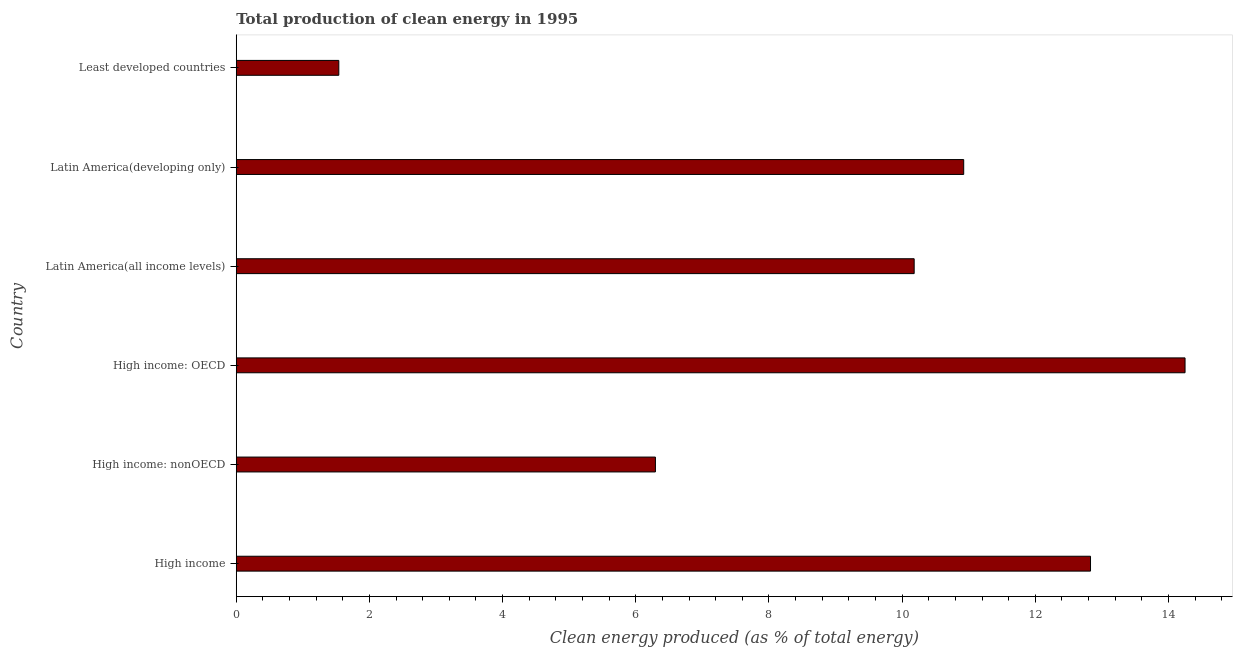Does the graph contain any zero values?
Your answer should be compact. No. Does the graph contain grids?
Offer a very short reply. No. What is the title of the graph?
Provide a short and direct response. Total production of clean energy in 1995. What is the label or title of the X-axis?
Your response must be concise. Clean energy produced (as % of total energy). What is the label or title of the Y-axis?
Keep it short and to the point. Country. What is the production of clean energy in Least developed countries?
Provide a succinct answer. 1.54. Across all countries, what is the maximum production of clean energy?
Offer a terse response. 14.25. Across all countries, what is the minimum production of clean energy?
Make the answer very short. 1.54. In which country was the production of clean energy maximum?
Your response must be concise. High income: OECD. In which country was the production of clean energy minimum?
Provide a short and direct response. Least developed countries. What is the sum of the production of clean energy?
Provide a short and direct response. 56.02. What is the difference between the production of clean energy in High income and High income: nonOECD?
Your response must be concise. 6.53. What is the average production of clean energy per country?
Offer a terse response. 9.34. What is the median production of clean energy?
Provide a succinct answer. 10.55. What is the ratio of the production of clean energy in High income to that in Least developed countries?
Give a very brief answer. 8.33. Is the difference between the production of clean energy in High income: OECD and High income: nonOECD greater than the difference between any two countries?
Your response must be concise. No. What is the difference between the highest and the second highest production of clean energy?
Give a very brief answer. 1.42. What is the difference between the highest and the lowest production of clean energy?
Make the answer very short. 12.71. In how many countries, is the production of clean energy greater than the average production of clean energy taken over all countries?
Make the answer very short. 4. How many bars are there?
Provide a short and direct response. 6. Are all the bars in the graph horizontal?
Provide a succinct answer. Yes. How many countries are there in the graph?
Keep it short and to the point. 6. What is the difference between two consecutive major ticks on the X-axis?
Keep it short and to the point. 2. Are the values on the major ticks of X-axis written in scientific E-notation?
Give a very brief answer. No. What is the Clean energy produced (as % of total energy) of High income?
Provide a short and direct response. 12.83. What is the Clean energy produced (as % of total energy) of High income: nonOECD?
Ensure brevity in your answer.  6.3. What is the Clean energy produced (as % of total energy) in High income: OECD?
Your answer should be very brief. 14.25. What is the Clean energy produced (as % of total energy) in Latin America(all income levels)?
Your answer should be very brief. 10.18. What is the Clean energy produced (as % of total energy) of Latin America(developing only)?
Your response must be concise. 10.92. What is the Clean energy produced (as % of total energy) in Least developed countries?
Ensure brevity in your answer.  1.54. What is the difference between the Clean energy produced (as % of total energy) in High income and High income: nonOECD?
Provide a short and direct response. 6.53. What is the difference between the Clean energy produced (as % of total energy) in High income and High income: OECD?
Offer a terse response. -1.42. What is the difference between the Clean energy produced (as % of total energy) in High income and Latin America(all income levels)?
Your response must be concise. 2.65. What is the difference between the Clean energy produced (as % of total energy) in High income and Latin America(developing only)?
Provide a short and direct response. 1.9. What is the difference between the Clean energy produced (as % of total energy) in High income and Least developed countries?
Keep it short and to the point. 11.29. What is the difference between the Clean energy produced (as % of total energy) in High income: nonOECD and High income: OECD?
Ensure brevity in your answer.  -7.95. What is the difference between the Clean energy produced (as % of total energy) in High income: nonOECD and Latin America(all income levels)?
Your answer should be compact. -3.89. What is the difference between the Clean energy produced (as % of total energy) in High income: nonOECD and Latin America(developing only)?
Make the answer very short. -4.63. What is the difference between the Clean energy produced (as % of total energy) in High income: nonOECD and Least developed countries?
Your answer should be compact. 4.75. What is the difference between the Clean energy produced (as % of total energy) in High income: OECD and Latin America(all income levels)?
Your answer should be very brief. 4.07. What is the difference between the Clean energy produced (as % of total energy) in High income: OECD and Latin America(developing only)?
Provide a succinct answer. 3.32. What is the difference between the Clean energy produced (as % of total energy) in High income: OECD and Least developed countries?
Ensure brevity in your answer.  12.71. What is the difference between the Clean energy produced (as % of total energy) in Latin America(all income levels) and Latin America(developing only)?
Make the answer very short. -0.74. What is the difference between the Clean energy produced (as % of total energy) in Latin America(all income levels) and Least developed countries?
Your answer should be very brief. 8.64. What is the difference between the Clean energy produced (as % of total energy) in Latin America(developing only) and Least developed countries?
Offer a terse response. 9.38. What is the ratio of the Clean energy produced (as % of total energy) in High income to that in High income: nonOECD?
Provide a succinct answer. 2.04. What is the ratio of the Clean energy produced (as % of total energy) in High income to that in Latin America(all income levels)?
Keep it short and to the point. 1.26. What is the ratio of the Clean energy produced (as % of total energy) in High income to that in Latin America(developing only)?
Keep it short and to the point. 1.17. What is the ratio of the Clean energy produced (as % of total energy) in High income to that in Least developed countries?
Offer a very short reply. 8.33. What is the ratio of the Clean energy produced (as % of total energy) in High income: nonOECD to that in High income: OECD?
Your answer should be compact. 0.44. What is the ratio of the Clean energy produced (as % of total energy) in High income: nonOECD to that in Latin America(all income levels)?
Your answer should be compact. 0.62. What is the ratio of the Clean energy produced (as % of total energy) in High income: nonOECD to that in Latin America(developing only)?
Your answer should be compact. 0.58. What is the ratio of the Clean energy produced (as % of total energy) in High income: nonOECD to that in Least developed countries?
Offer a terse response. 4.09. What is the ratio of the Clean energy produced (as % of total energy) in High income: OECD to that in Latin America(all income levels)?
Your response must be concise. 1.4. What is the ratio of the Clean energy produced (as % of total energy) in High income: OECD to that in Latin America(developing only)?
Offer a very short reply. 1.3. What is the ratio of the Clean energy produced (as % of total energy) in High income: OECD to that in Least developed countries?
Your answer should be very brief. 9.25. What is the ratio of the Clean energy produced (as % of total energy) in Latin America(all income levels) to that in Latin America(developing only)?
Make the answer very short. 0.93. What is the ratio of the Clean energy produced (as % of total energy) in Latin America(all income levels) to that in Least developed countries?
Your answer should be compact. 6.61. What is the ratio of the Clean energy produced (as % of total energy) in Latin America(developing only) to that in Least developed countries?
Your answer should be very brief. 7.09. 